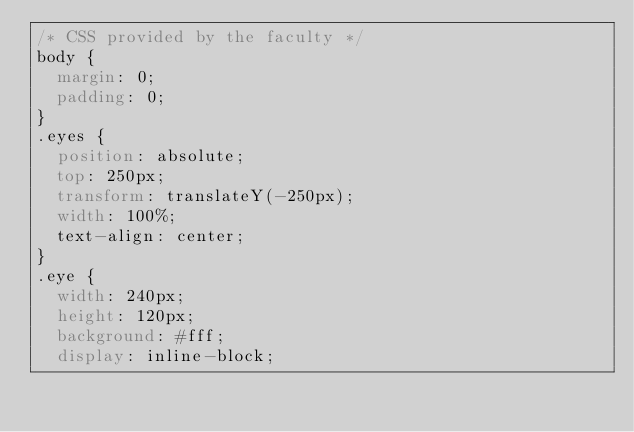<code> <loc_0><loc_0><loc_500><loc_500><_CSS_>/* CSS provided by the faculty */
body {
  margin: 0;
  padding: 0;
}
.eyes {
  position: absolute;
  top: 250px;
  transform: translateY(-250px);
  width: 100%;
  text-align: center;
}
.eye {
  width: 240px;
  height: 120px;
  background: #fff;
  display: inline-block;</code> 